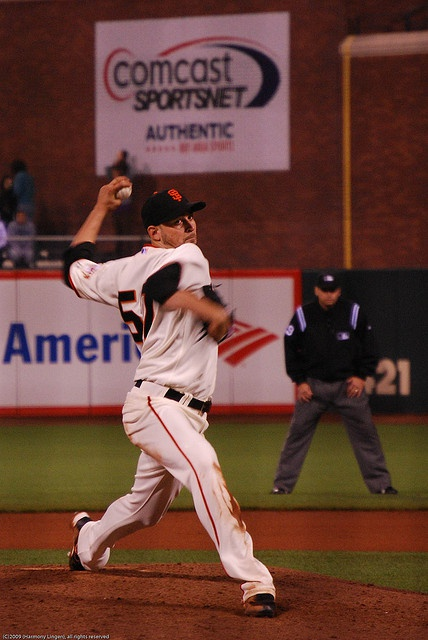Describe the objects in this image and their specific colors. I can see people in maroon, pink, black, and brown tones, people in maroon, black, olive, and gray tones, people in black and maroon tones, people in maroon, black, and purple tones, and people in black and maroon tones in this image. 